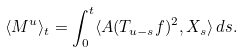<formula> <loc_0><loc_0><loc_500><loc_500>\langle M ^ { u } \rangle _ { t } = \int _ { 0 } ^ { t } \langle A ( T _ { u - s } f ) ^ { 2 } , X _ { s } \rangle \, d s .</formula> 